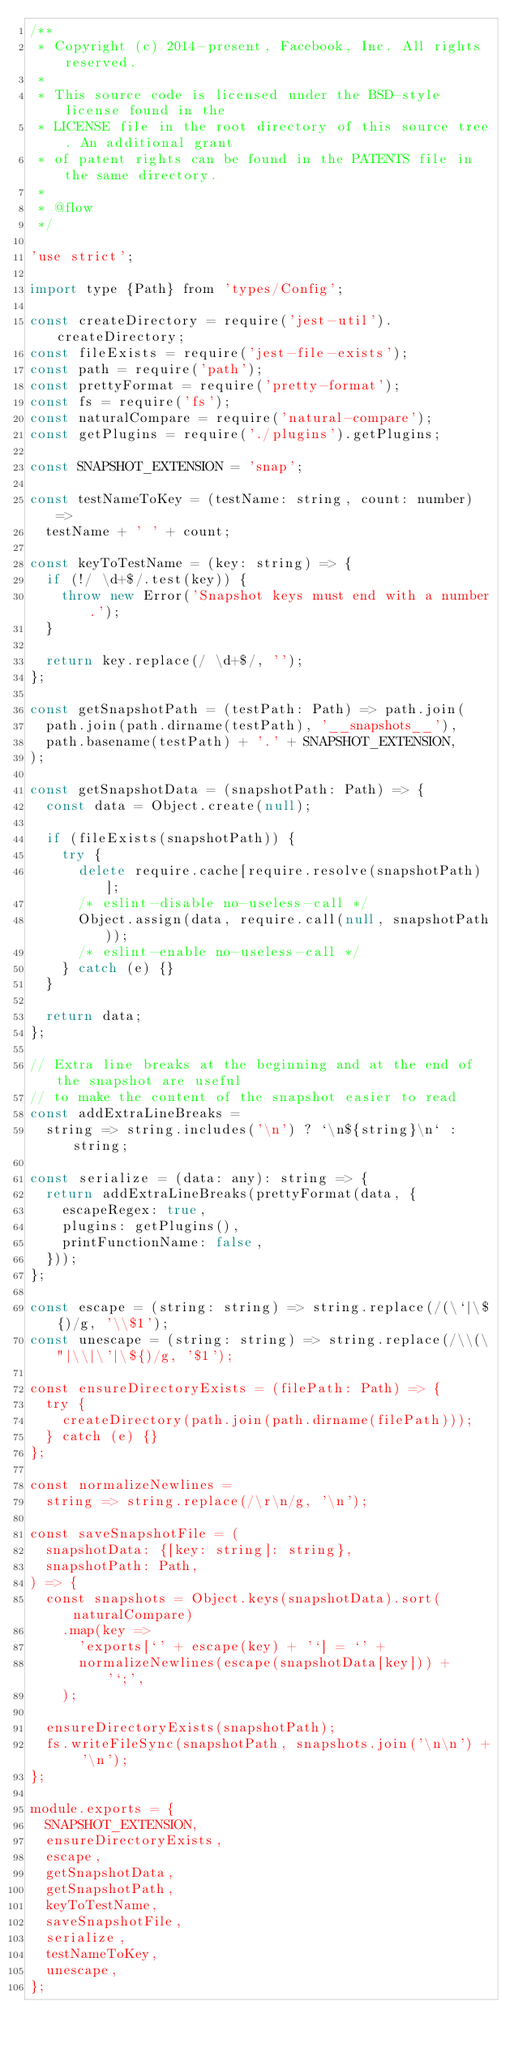Convert code to text. <code><loc_0><loc_0><loc_500><loc_500><_JavaScript_>/**
 * Copyright (c) 2014-present, Facebook, Inc. All rights reserved.
 *
 * This source code is licensed under the BSD-style license found in the
 * LICENSE file in the root directory of this source tree. An additional grant
 * of patent rights can be found in the PATENTS file in the same directory.
 *
 * @flow
 */

'use strict';

import type {Path} from 'types/Config';

const createDirectory = require('jest-util').createDirectory;
const fileExists = require('jest-file-exists');
const path = require('path');
const prettyFormat = require('pretty-format');
const fs = require('fs');
const naturalCompare = require('natural-compare');
const getPlugins = require('./plugins').getPlugins;

const SNAPSHOT_EXTENSION = 'snap';

const testNameToKey = (testName: string, count: number) =>
  testName + ' ' + count;

const keyToTestName = (key: string) => {
  if (!/ \d+$/.test(key)) {
    throw new Error('Snapshot keys must end with a number.');
  }

  return key.replace(/ \d+$/, '');
};

const getSnapshotPath = (testPath: Path) => path.join(
  path.join(path.dirname(testPath), '__snapshots__'),
  path.basename(testPath) + '.' + SNAPSHOT_EXTENSION,
);

const getSnapshotData = (snapshotPath: Path) => {
  const data = Object.create(null);

  if (fileExists(snapshotPath)) {
    try {
      delete require.cache[require.resolve(snapshotPath)];
      /* eslint-disable no-useless-call */
      Object.assign(data, require.call(null, snapshotPath));
      /* eslint-enable no-useless-call */
    } catch (e) {}
  }

  return data;
};

// Extra line breaks at the beginning and at the end of the snapshot are useful
// to make the content of the snapshot easier to read
const addExtraLineBreaks =
  string => string.includes('\n') ? `\n${string}\n` : string;

const serialize = (data: any): string => {
  return addExtraLineBreaks(prettyFormat(data, {
    escapeRegex: true,
    plugins: getPlugins(),
    printFunctionName: false,
  }));
};

const escape = (string: string) => string.replace(/(\`|\${)/g, '\\$1');
const unescape = (string: string) => string.replace(/\\(\"|\\|\'|\${)/g, '$1');

const ensureDirectoryExists = (filePath: Path) => {
  try {
    createDirectory(path.join(path.dirname(filePath)));
  } catch (e) {}
};

const normalizeNewlines =
  string => string.replace(/\r\n/g, '\n');

const saveSnapshotFile = (
  snapshotData: {[key: string]: string},
  snapshotPath: Path,
) => {
  const snapshots = Object.keys(snapshotData).sort(naturalCompare)
    .map(key =>
      'exports[`' + escape(key) + '`] = `' +
      normalizeNewlines(escape(snapshotData[key])) + '`;',
    );

  ensureDirectoryExists(snapshotPath);
  fs.writeFileSync(snapshotPath, snapshots.join('\n\n') + '\n');
};

module.exports = {
  SNAPSHOT_EXTENSION,
  ensureDirectoryExists,
  escape,
  getSnapshotData,
  getSnapshotPath,
  keyToTestName,
  saveSnapshotFile,
  serialize,
  testNameToKey,
  unescape,
};
</code> 